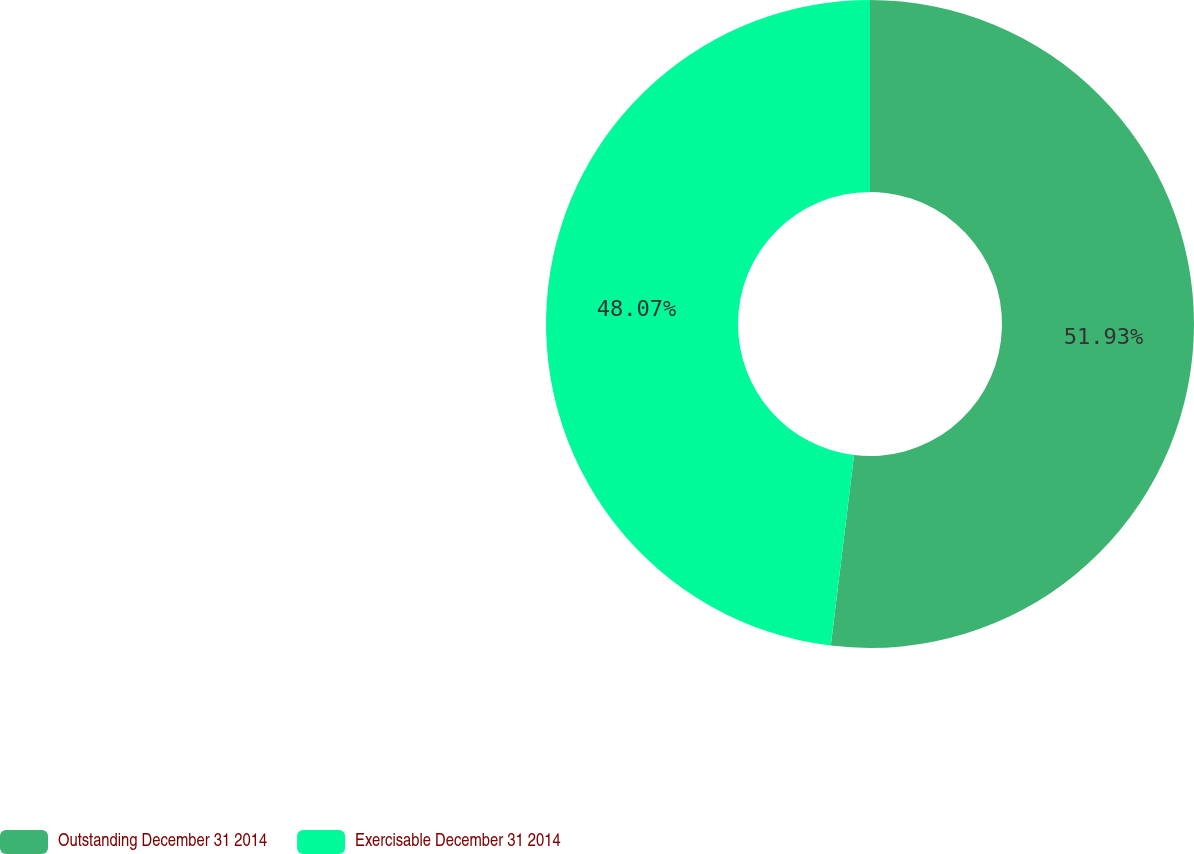<chart> <loc_0><loc_0><loc_500><loc_500><pie_chart><fcel>Outstanding December 31 2014<fcel>Exercisable December 31 2014<nl><fcel>51.93%<fcel>48.07%<nl></chart> 